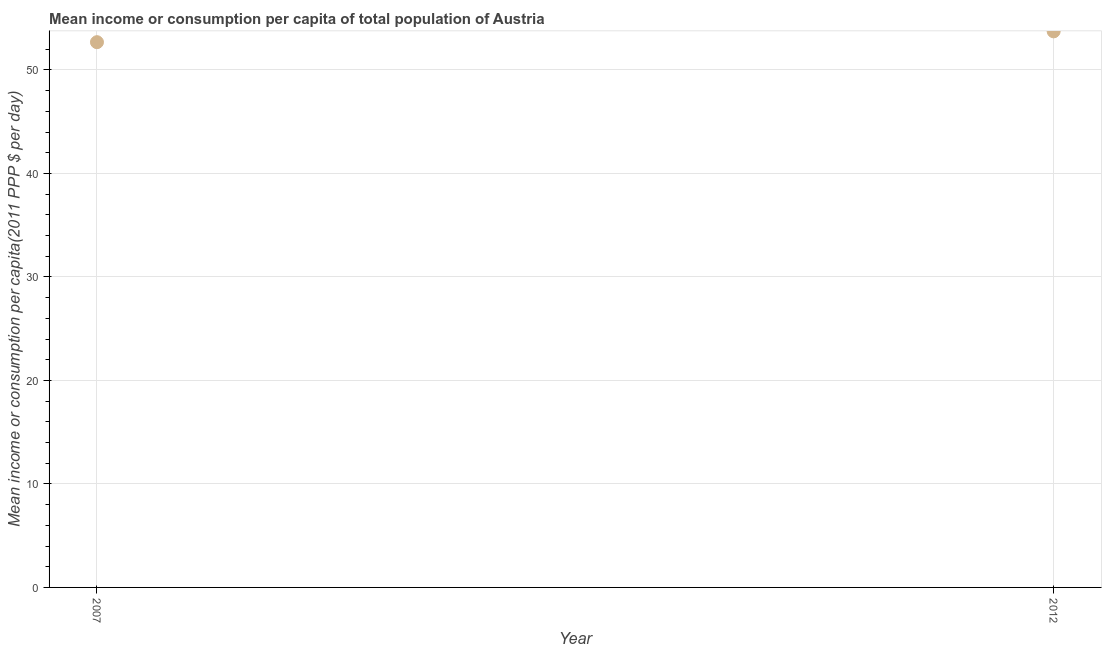What is the mean income or consumption in 2012?
Your answer should be compact. 53.73. Across all years, what is the maximum mean income or consumption?
Give a very brief answer. 53.73. Across all years, what is the minimum mean income or consumption?
Make the answer very short. 52.68. In which year was the mean income or consumption maximum?
Your answer should be compact. 2012. In which year was the mean income or consumption minimum?
Provide a succinct answer. 2007. What is the sum of the mean income or consumption?
Give a very brief answer. 106.41. What is the difference between the mean income or consumption in 2007 and 2012?
Offer a terse response. -1.04. What is the average mean income or consumption per year?
Offer a very short reply. 53.21. What is the median mean income or consumption?
Your response must be concise. 53.21. Do a majority of the years between 2007 and 2012 (inclusive) have mean income or consumption greater than 6 $?
Make the answer very short. Yes. What is the ratio of the mean income or consumption in 2007 to that in 2012?
Make the answer very short. 0.98. Is the mean income or consumption in 2007 less than that in 2012?
Offer a very short reply. Yes. In how many years, is the mean income or consumption greater than the average mean income or consumption taken over all years?
Keep it short and to the point. 1. Does the mean income or consumption monotonically increase over the years?
Offer a very short reply. Yes. How many dotlines are there?
Your response must be concise. 1. How many years are there in the graph?
Ensure brevity in your answer.  2. What is the difference between two consecutive major ticks on the Y-axis?
Offer a very short reply. 10. Are the values on the major ticks of Y-axis written in scientific E-notation?
Your response must be concise. No. Does the graph contain any zero values?
Your answer should be very brief. No. Does the graph contain grids?
Your answer should be very brief. Yes. What is the title of the graph?
Give a very brief answer. Mean income or consumption per capita of total population of Austria. What is the label or title of the X-axis?
Your answer should be compact. Year. What is the label or title of the Y-axis?
Offer a terse response. Mean income or consumption per capita(2011 PPP $ per day). What is the Mean income or consumption per capita(2011 PPP $ per day) in 2007?
Offer a very short reply. 52.68. What is the Mean income or consumption per capita(2011 PPP $ per day) in 2012?
Your answer should be very brief. 53.73. What is the difference between the Mean income or consumption per capita(2011 PPP $ per day) in 2007 and 2012?
Offer a terse response. -1.04. 